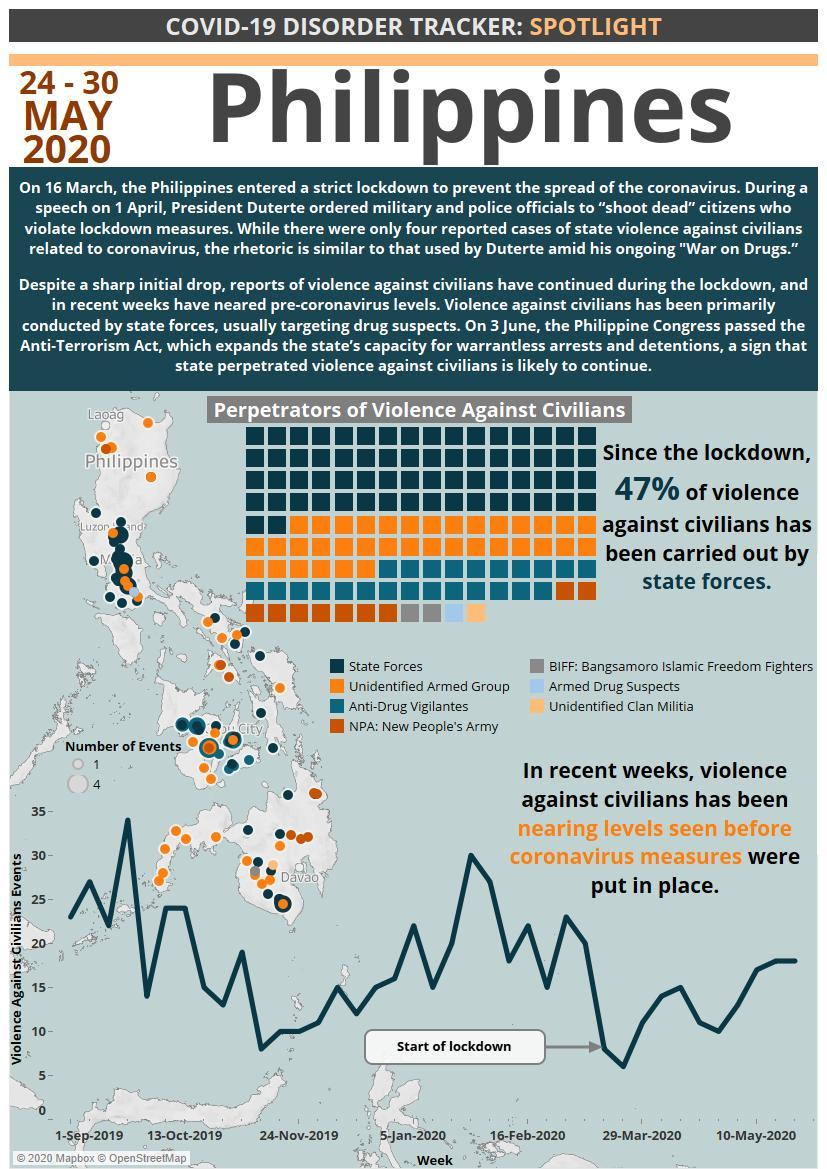Which two groups were responsible for the lowest number of violence cases?
Answer the question with a short phrase. Armed drug suspects, unidentified clan militia Who was responsible for the second highest number of violence cases against citizens? unidentified armed group 